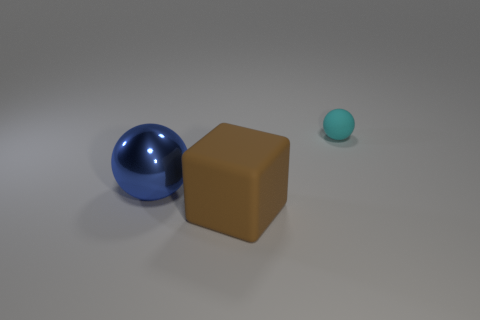Are there an equal number of matte spheres that are in front of the large shiny ball and blue metallic spheres to the right of the big brown thing?
Make the answer very short. Yes. There is a rubber object in front of the ball that is left of the big brown rubber block; how many large blocks are on the left side of it?
Offer a very short reply. 0. There is a rubber cube; does it have the same color as the sphere on the right side of the large blue metallic object?
Keep it short and to the point. No. What size is the brown object that is the same material as the tiny cyan sphere?
Keep it short and to the point. Large. Is the number of blue metal spheres behind the large shiny object greater than the number of purple metallic balls?
Your answer should be compact. No. There is a thing that is in front of the sphere that is in front of the rubber thing behind the brown block; what is its material?
Provide a succinct answer. Rubber. Do the tiny cyan thing and the large thing that is right of the blue metal thing have the same material?
Keep it short and to the point. Yes. What material is the large blue thing that is the same shape as the cyan rubber object?
Make the answer very short. Metal. Is there any other thing that has the same material as the big blue object?
Keep it short and to the point. No. Is the number of blue balls that are right of the large block greater than the number of shiny spheres that are on the right side of the cyan matte ball?
Make the answer very short. No. 